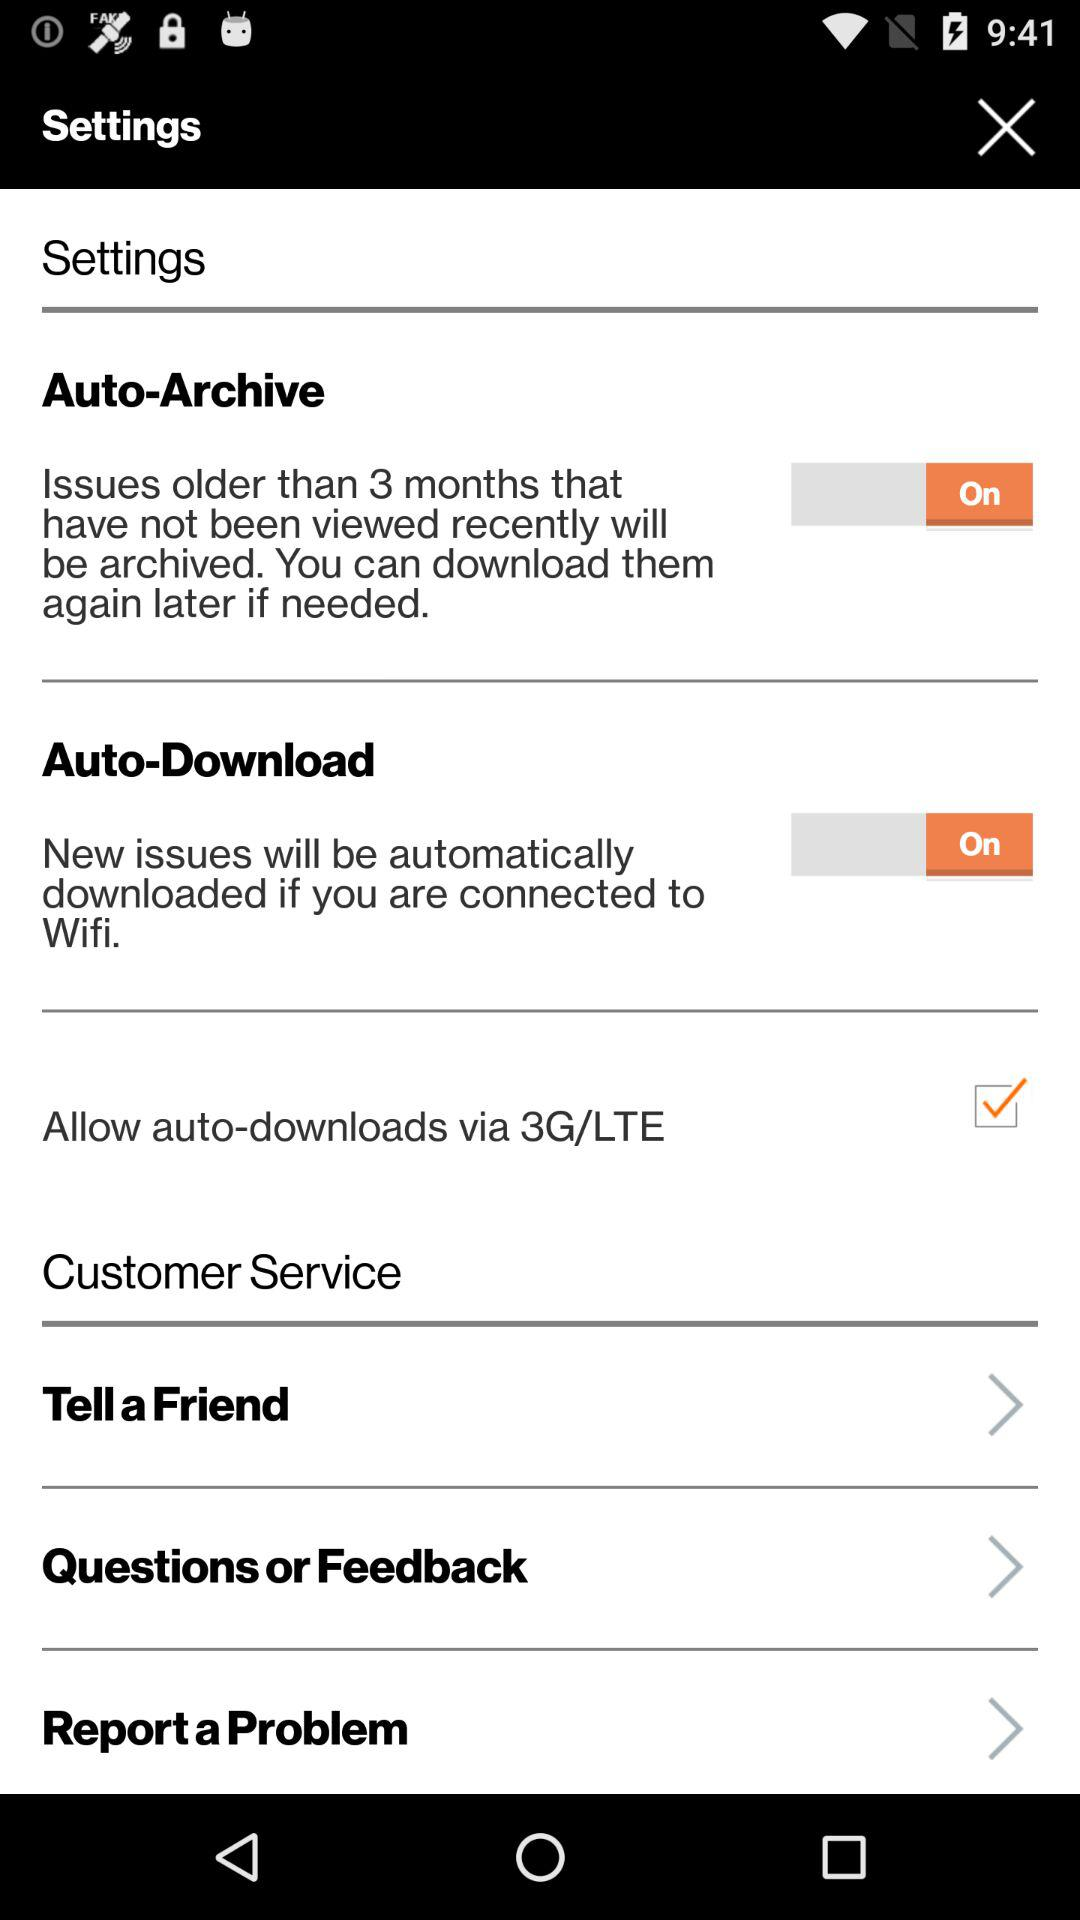What is the status of "Auto-Archive"? The status of "Auto-Archive" is "on". 